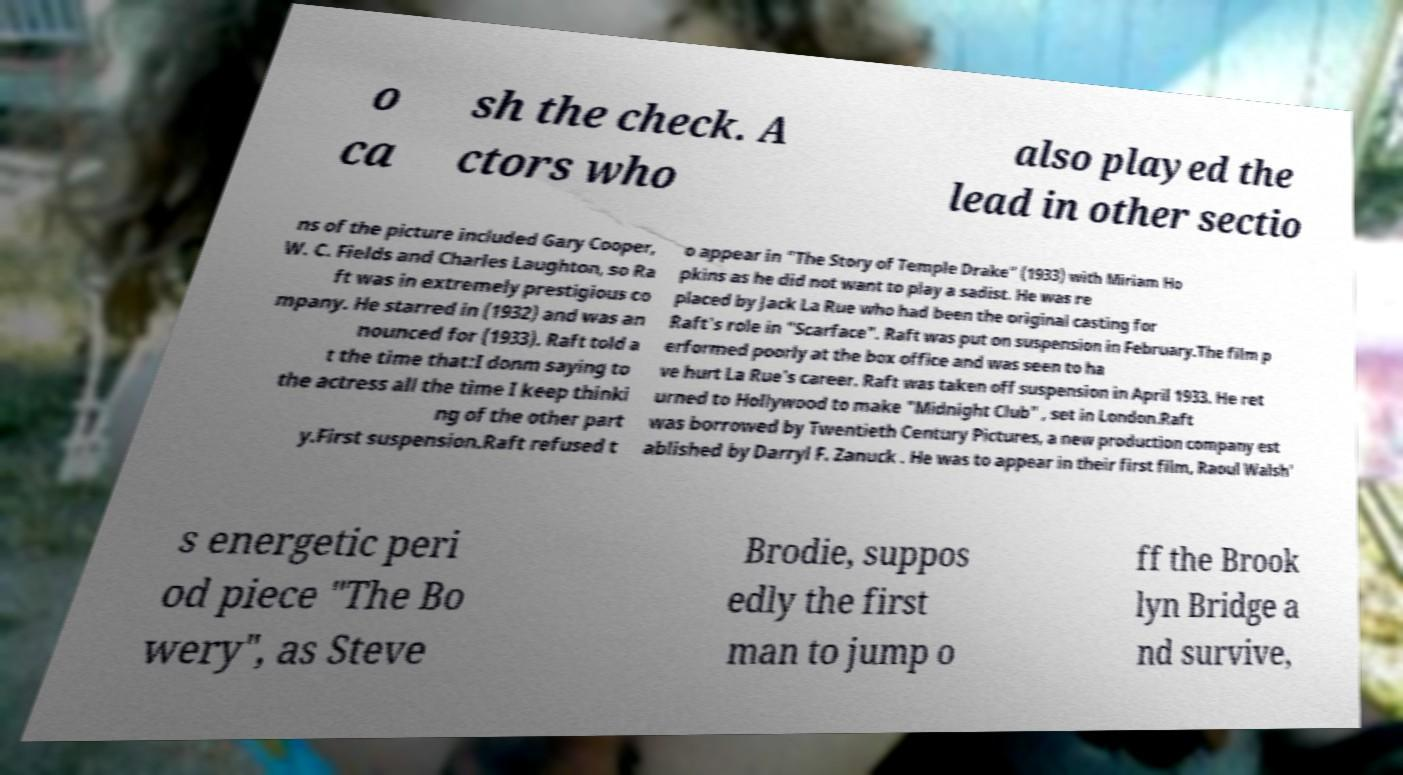Can you accurately transcribe the text from the provided image for me? o ca sh the check. A ctors who also played the lead in other sectio ns of the picture included Gary Cooper, W. C. Fields and Charles Laughton, so Ra ft was in extremely prestigious co mpany. He starred in (1932) and was an nounced for (1933). Raft told a t the time that:I donm saying to the actress all the time I keep thinki ng of the other part y.First suspension.Raft refused t o appear in "The Story of Temple Drake" (1933) with Miriam Ho pkins as he did not want to play a sadist. He was re placed by Jack La Rue who had been the original casting for Raft's role in "Scarface". Raft was put on suspension in February.The film p erformed poorly at the box office and was seen to ha ve hurt La Rue's career. Raft was taken off suspension in April 1933. He ret urned to Hollywood to make "Midnight Club" , set in London.Raft was borrowed by Twentieth Century Pictures, a new production company est ablished by Darryl F. Zanuck . He was to appear in their first film, Raoul Walsh' s energetic peri od piece "The Bo wery", as Steve Brodie, suppos edly the first man to jump o ff the Brook lyn Bridge a nd survive, 